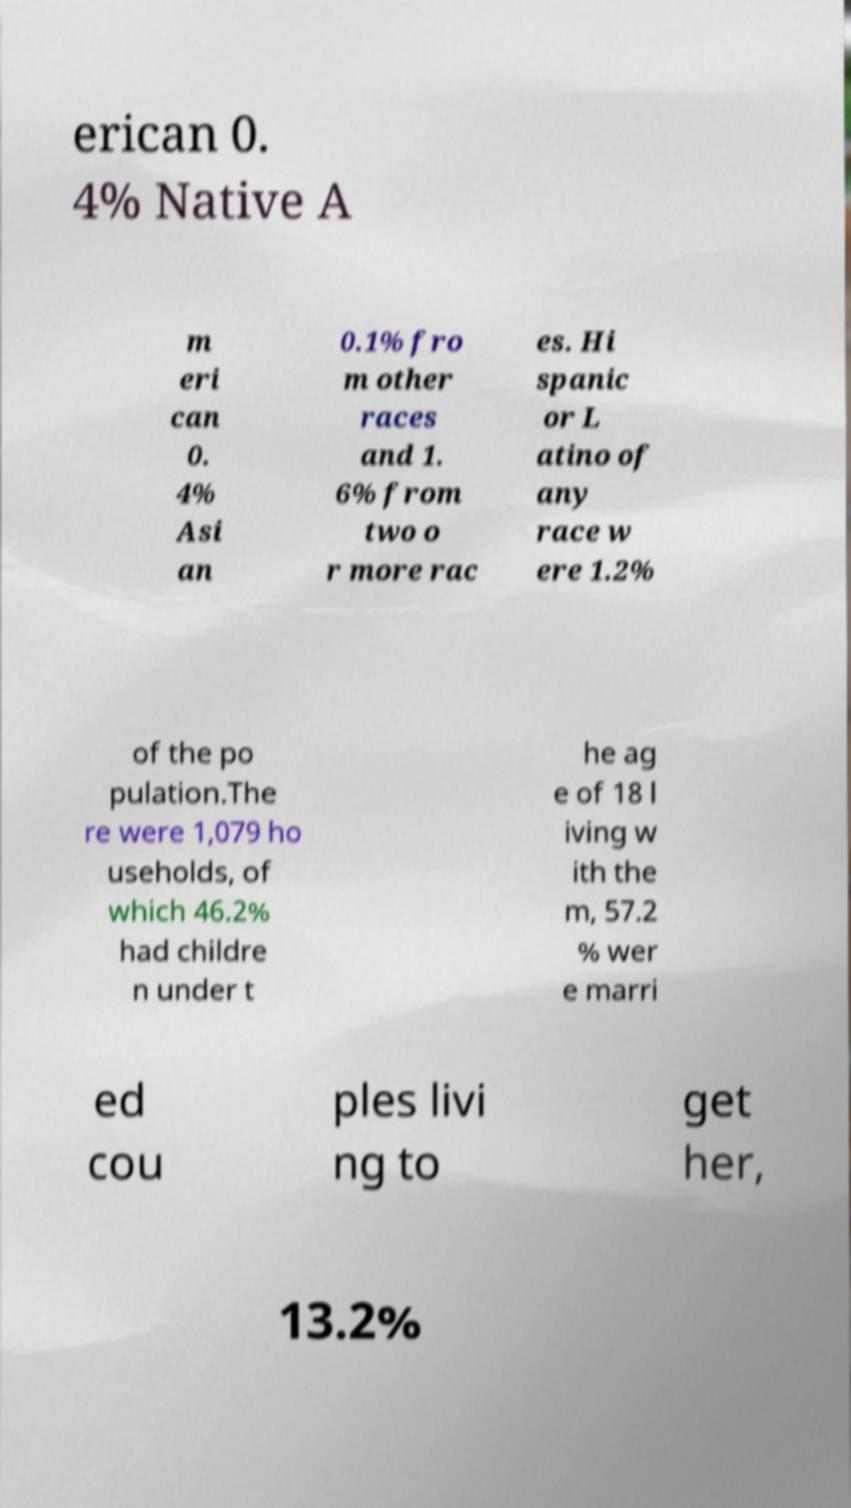What messages or text are displayed in this image? I need them in a readable, typed format. erican 0. 4% Native A m eri can 0. 4% Asi an 0.1% fro m other races and 1. 6% from two o r more rac es. Hi spanic or L atino of any race w ere 1.2% of the po pulation.The re were 1,079 ho useholds, of which 46.2% had childre n under t he ag e of 18 l iving w ith the m, 57.2 % wer e marri ed cou ples livi ng to get her, 13.2% 